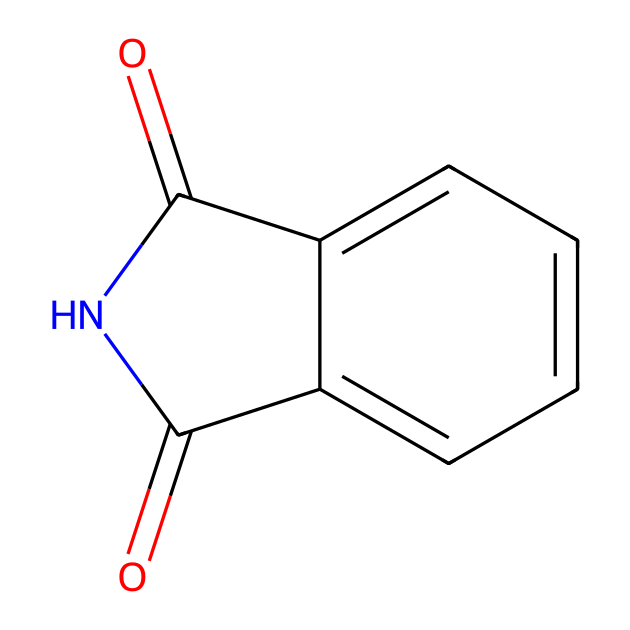What is the main functional group in phthalimide? The main functional group present in phthalimide is the imide group, characterized by the presence of a nitrogen atom bonded to two carbonyl (C=O) groups. This is evident from the chemical structure.
Answer: imide group How many carbon atoms are in phthalimide? Counting the carbon atoms in the SMILES representation, we see that there are eight carbon atoms within the ring structure and the two carbonyl groups combined, totaling eight.
Answer: eight What is the total number of nitrogen atoms in phthalimide? In the structure, there is one nitrogen atom present, which is part of the imide functional group.
Answer: one Which part of the structure contributes to its potential use in pigments? The fused benzene ring and the carbonyl groups in the structure contribute to the stability and color properties, which are essential in pigments. These features allow for good light absorption and color retention.
Answer: fused benzene ring Is phthalimide a saturated or unsaturated compound? The compound has a double bond in its structure (the carbonyl groups), indicating that it contains both single and double bonds, thus making it unsaturated.
Answer: unsaturated What type of chemical reaction can phthalimide undergo? Phthalimide can undergo hydrolysis to form phthalic acid and ammonia, which is a type of reaction typical for imides.
Answer: hydrolysis 